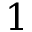Convert formula to latex. <formula><loc_0><loc_0><loc_500><loc_500>1</formula> 